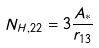Convert formula to latex. <formula><loc_0><loc_0><loc_500><loc_500>N _ { H , 2 2 } = 3 \frac { A _ { * } } { r _ { 1 3 } }</formula> 